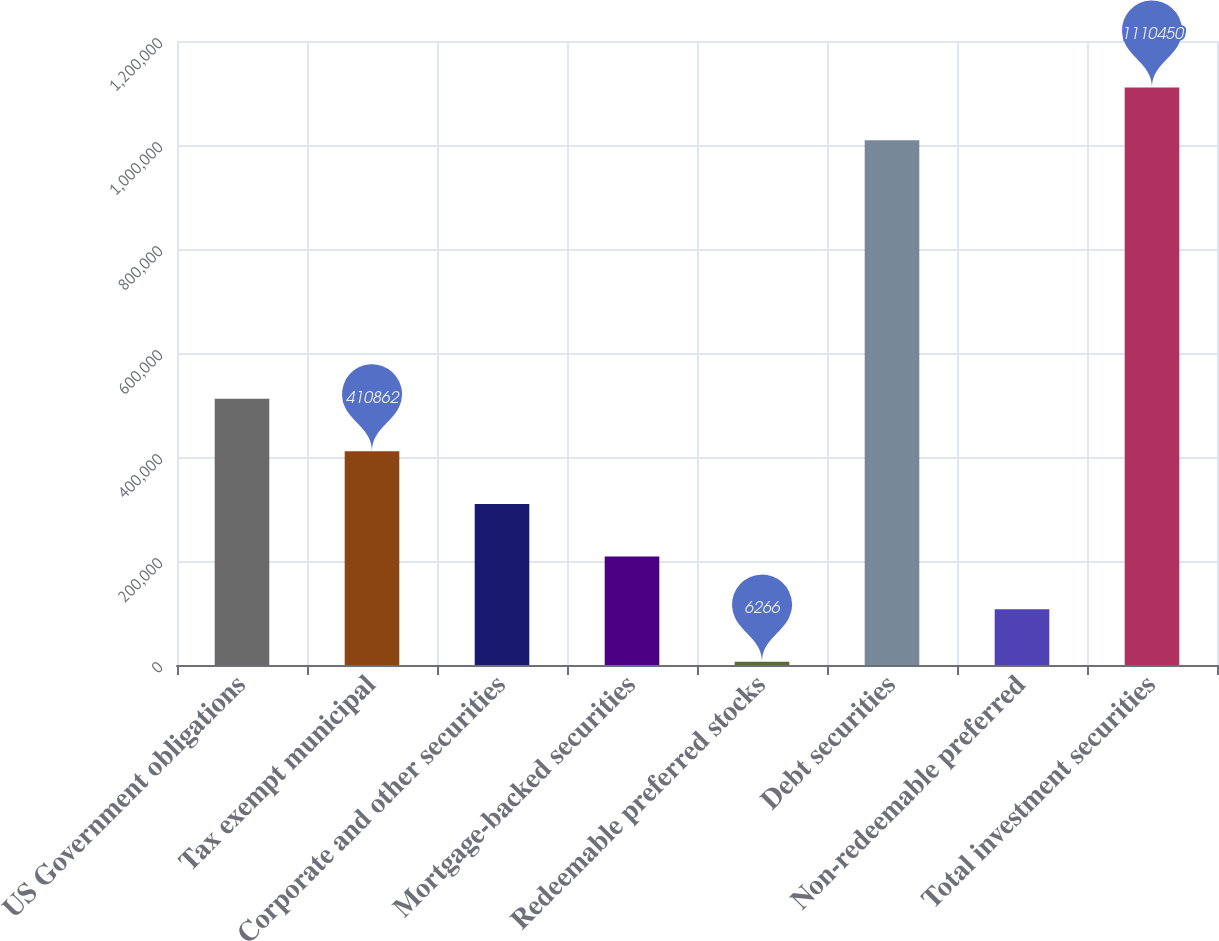Convert chart. <chart><loc_0><loc_0><loc_500><loc_500><bar_chart><fcel>US Government obligations<fcel>Tax exempt municipal<fcel>Corporate and other securities<fcel>Mortgage-backed securities<fcel>Redeemable preferred stocks<fcel>Debt securities<fcel>Non-redeemable preferred<fcel>Total investment securities<nl><fcel>512011<fcel>410862<fcel>309713<fcel>208564<fcel>6266<fcel>1.0093e+06<fcel>107415<fcel>1.11045e+06<nl></chart> 